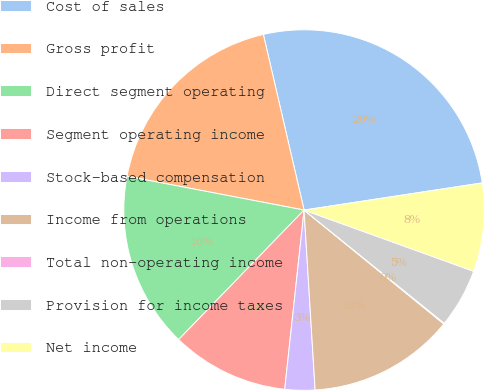Convert chart to OTSL. <chart><loc_0><loc_0><loc_500><loc_500><pie_chart><fcel>Cost of sales<fcel>Gross profit<fcel>Direct segment operating<fcel>Segment operating income<fcel>Stock-based compensation<fcel>Income from operations<fcel>Total non-operating income<fcel>Provision for income taxes<fcel>Net income<nl><fcel>26.22%<fcel>18.37%<fcel>15.76%<fcel>10.53%<fcel>2.69%<fcel>13.14%<fcel>0.07%<fcel>5.3%<fcel>7.92%<nl></chart> 